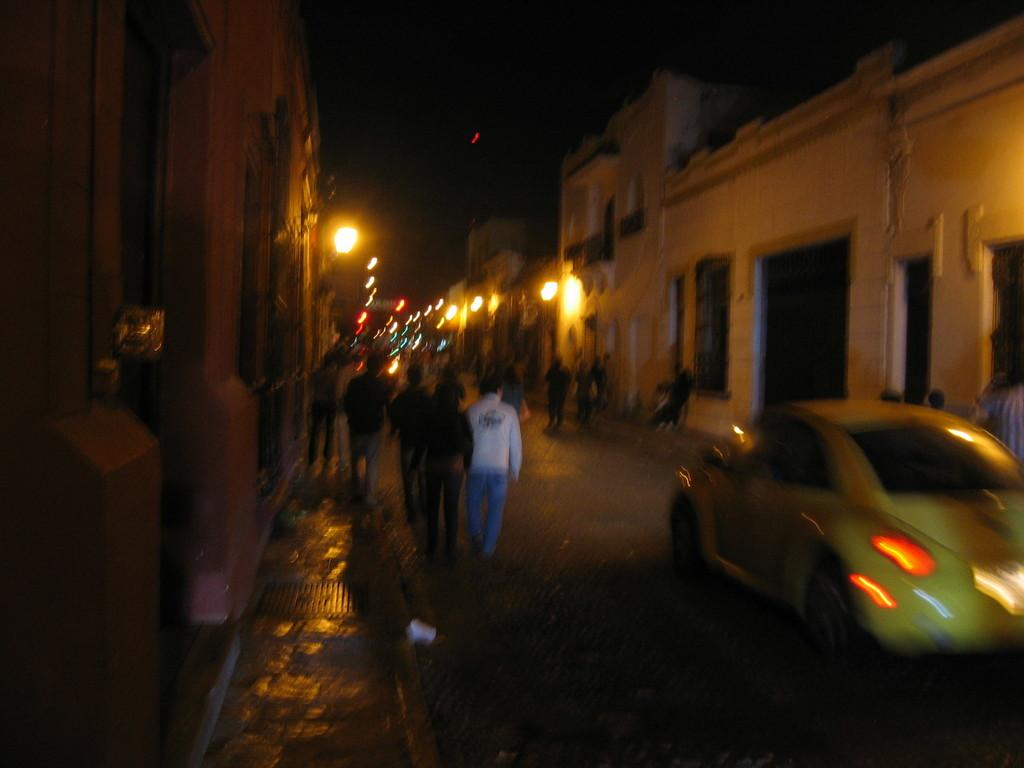What type of vehicle is on the road in the image? There is a car on the road in the image. What are the people in the image doing? There are people walking in the image. What can be seen on either side of the road in the image? There are buildings on either side of the road in the image. What is visible in the image that might provide illumination? There are lights visible in the image. What type of sugar is being used to stitch the boat in the image? There is no boat, sugar, or stitching present in the image. 